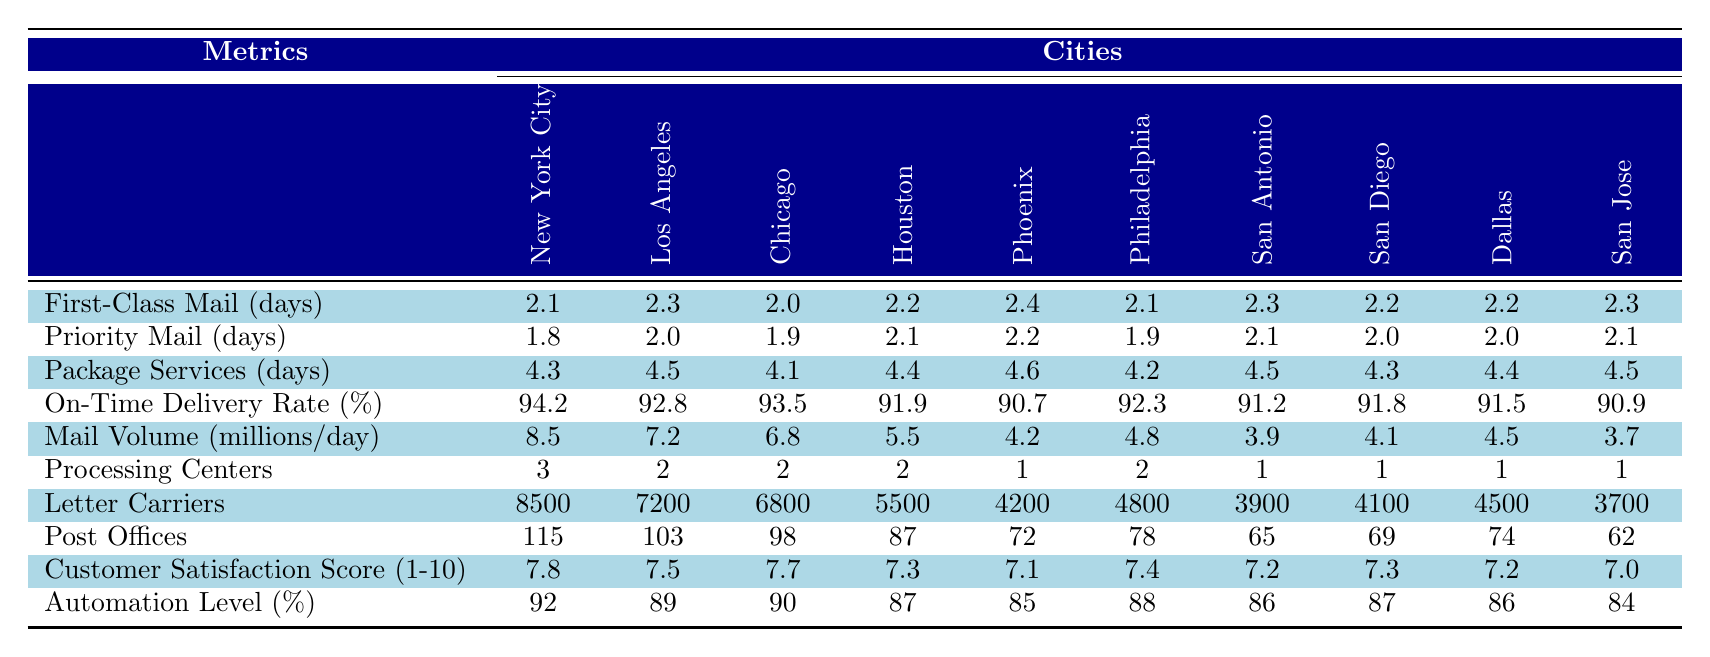What city has the highest first-class mail delivery time? The delivery times for first-class mail in the table are: New York City (2.1), Los Angeles (2.3), Chicago (2.0), Houston (2.2), Phoenix (2.4), Philadelphia (2.1), San Antonio (2.3), San Diego (2.2), Dallas (2.2), and San Jose (2.3). Among these, Phoenix has the highest delivery time of 2.4 days.
Answer: Phoenix Which city has the lowest on-time delivery rate? The on-time delivery rates listed are for New York City (94.2%), Los Angeles (92.8%), Chicago (93.5%), Houston (91.9%), Phoenix (90.7%), Philadelphia (92.3%), San Antonio (91.2%), San Diego (91.8%), Dallas (91.5%), and San Jose (90.9%). The lowest rate is for Phoenix at 90.7%.
Answer: Phoenix How many processing centers does San Diego have compared to New York City? San Diego has 1 processing center while New York City has 3. Therefore, New York City has 2 more processing centers than San Diego.
Answer: New York City has 2 more What is the average customer satisfaction score across all cities? The customer satisfaction scores are 7.8, 7.5, 7.7, 7.3, 7.1, 7.4, 7.2, 7.3, 7.2, and 7.0. Summing these gives 74.5, and dividing by 10 provides an average score of 7.45.
Answer: 7.45 True or False: Los Angeles has more letter carriers than Philadelphia. The number of letter carriers is 7200 for Los Angeles and 4800 for Philadelphia. Since 7200 is greater than 4800, the statement is true.
Answer: True Which city has both the highest and lowest automation level? The highest automation level is in New York City at 92%, and the lowest is in San Jose at 84%. Therefore, New York City has the highest while San Jose has the lowest.
Answer: New York City has the highest; San Jose has the lowest What is the total mail volume for the cities with more than 8 million mail volume? The only city with more than 8 million mail volume is New York City with 8.5 million. Thus, the total mail volume for cities with more than 8 million is just 8.5 million.
Answer: 8.5 million 